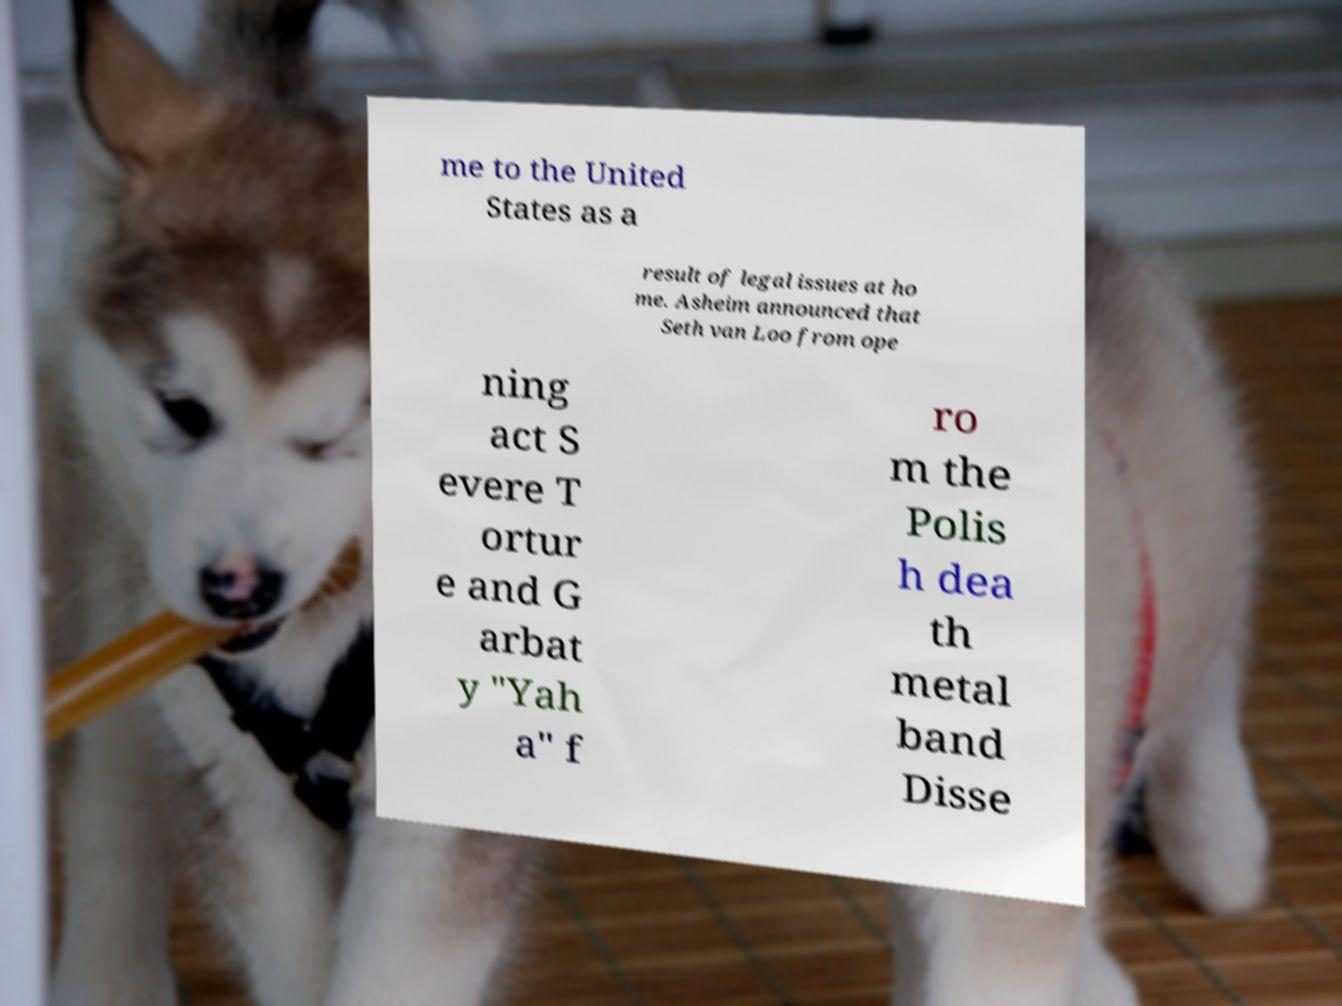Can you accurately transcribe the text from the provided image for me? me to the United States as a result of legal issues at ho me. Asheim announced that Seth van Loo from ope ning act S evere T ortur e and G arbat y "Yah a" f ro m the Polis h dea th metal band Disse 